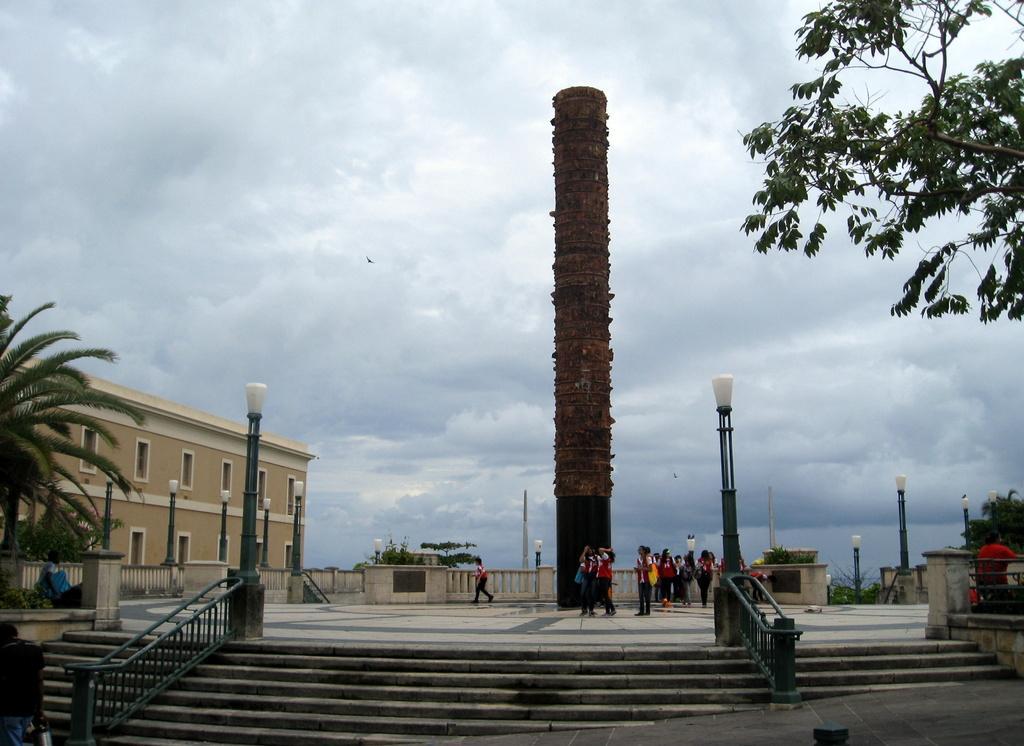Can you describe this image briefly? In this image I can see a building, trees, pole lights, steps, a pillar, fence and other objects. In the background I can see the sky. 